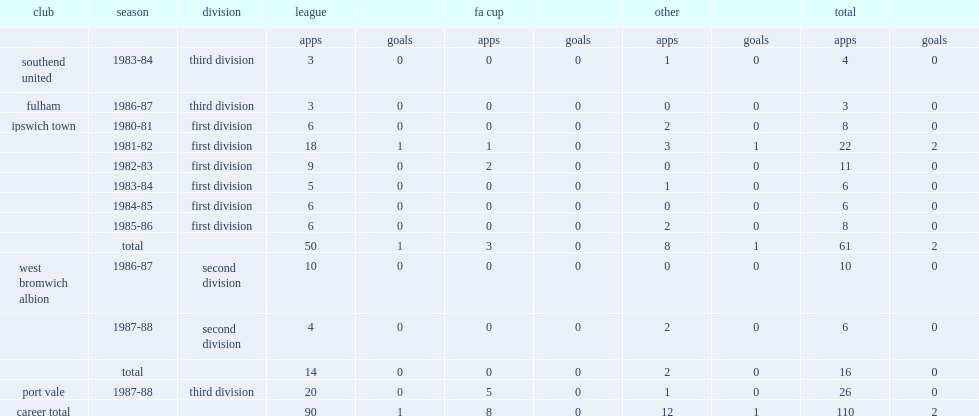Which club did steggles play for in 1980-81? Ipswich town. 